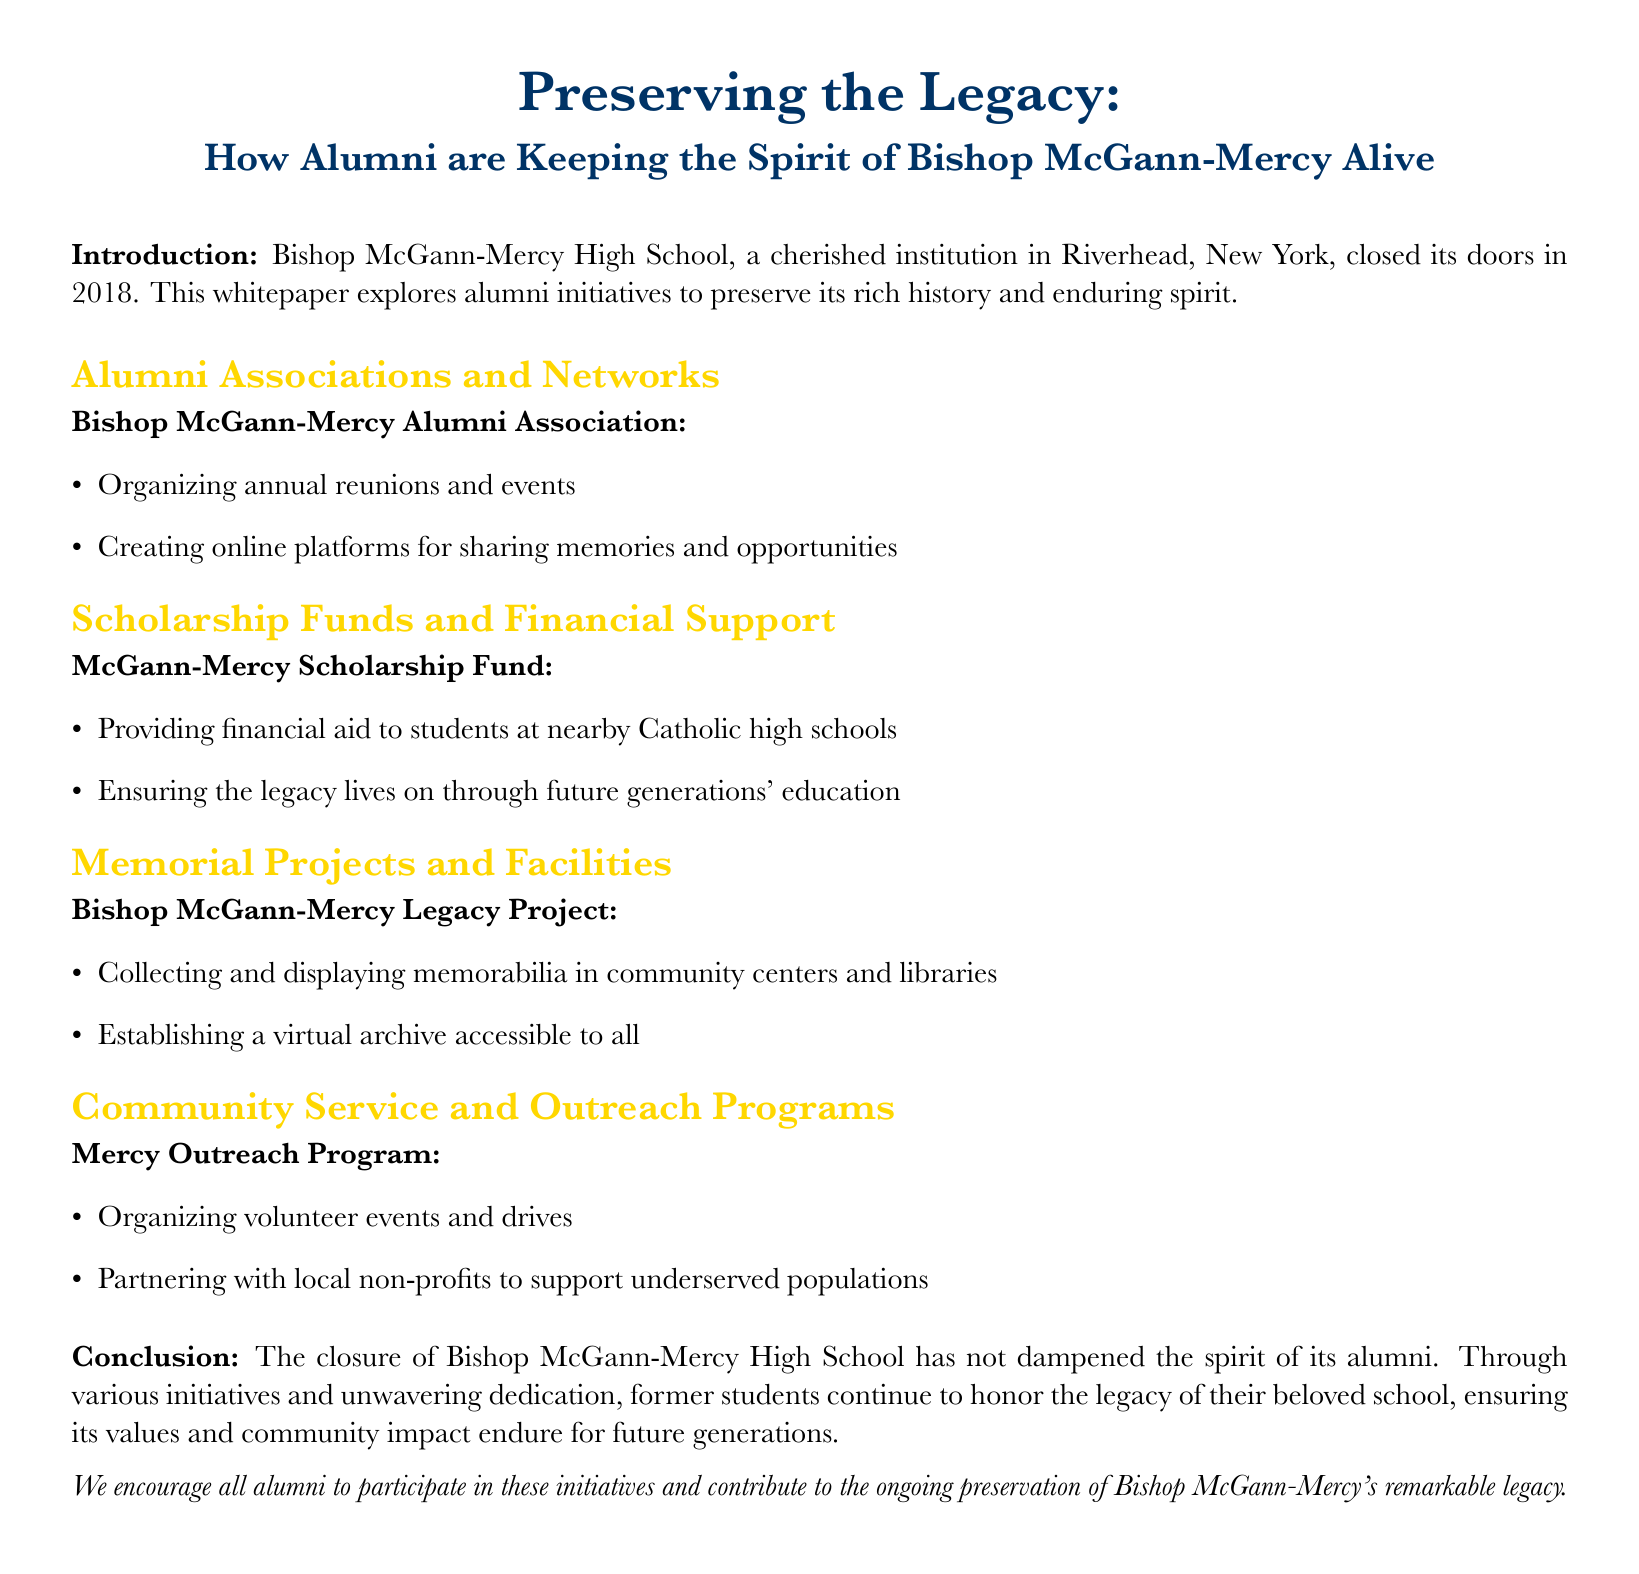What year did Bishop McGann-Mercy High School close? The document explicitly states that the school closed its doors in the year 2018.
Answer: 2018 What is the name of the alumni association mentioned? The document refers to the Bishop McGann-Mercy Alumni Association as the main alumni group.
Answer: Bishop McGann-Mercy Alumni Association What program organizes volunteer events? The Mercy Outreach Program is identified as the initiative that organizes volunteer events and drives.
Answer: Mercy Outreach Program What is the purpose of the McGann-Mercy Scholarship Fund? The document explains that the fund provides financial aid to students at nearby Catholic high schools to ensure the school's legacy continues.
Answer: Financial aid How are memorabilia being preserved according to the document? The Bishop McGann-Mercy Legacy Project is responsible for collecting and displaying memorabilia in community centers and libraries.
Answer: Collecting and displaying memorabilia What color is used for the section titles in the document? The section titles are colored mercy gold, as noted in the document's formatting specifications.
Answer: mercy gold What type of document is this? The content and structure indicate this is a whitepaper discussing alumni initiatives regarding the school.
Answer: Whitepaper What is the main focus of the conclusion? The conclusion emphasizes that alumni continue to honor the legacy of Bishop McGann-Mercy High School despite its closure.
Answer: Honor the legacy 